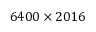<formula> <loc_0><loc_0><loc_500><loc_500>6 4 0 0 \times 2 0 1 6</formula> 